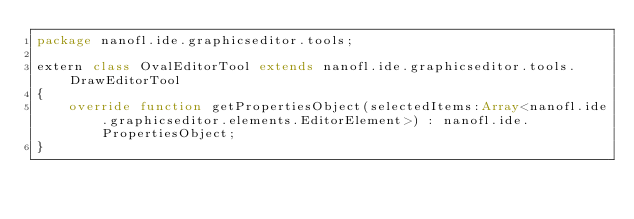<code> <loc_0><loc_0><loc_500><loc_500><_Haxe_>package nanofl.ide.graphicseditor.tools;

extern class OvalEditorTool extends nanofl.ide.graphicseditor.tools.DrawEditorTool
{
	override function getPropertiesObject(selectedItems:Array<nanofl.ide.graphicseditor.elements.EditorElement>) : nanofl.ide.PropertiesObject;
}</code> 